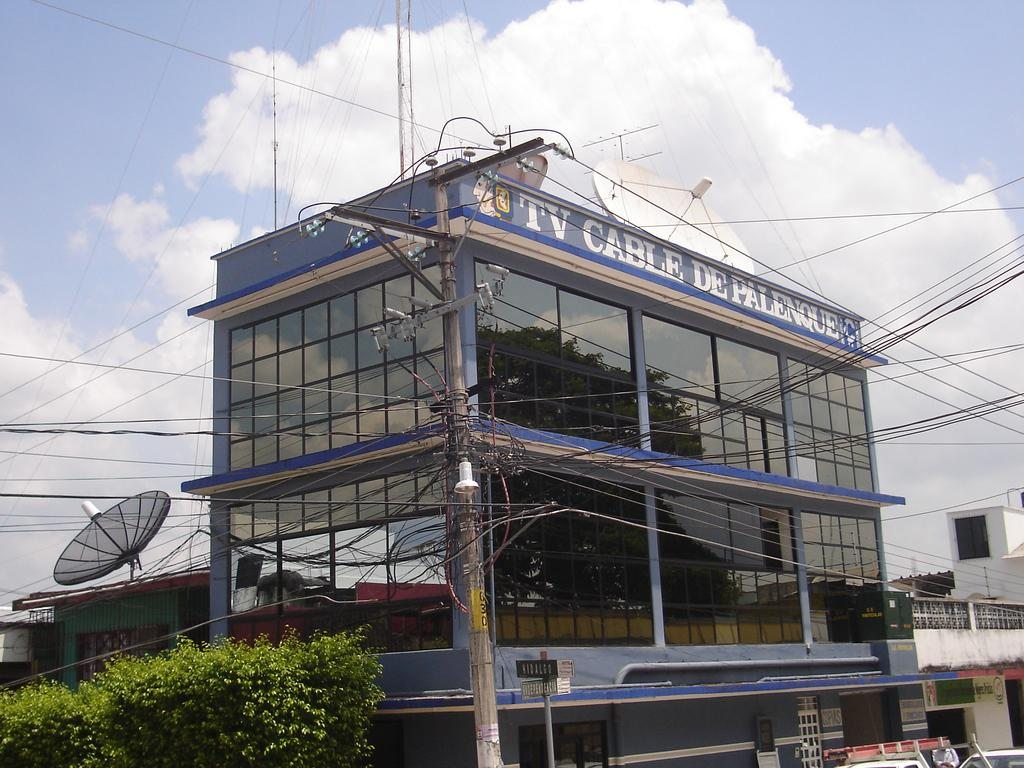What type of structure is present in the image? There is a building in the image. What type of vegetation is visible in the image? There are green trees in the image. What is visible at the top of the image? The sky is visible at the top of the image. What can be seen in the sky? There are clouds in the sky. How many patches are on the van in the image? There is no van present in the image, so there are no patches to count. What type of zephyr can be seen blowing through the trees in the image? There is no zephyr mentioned or visible in the image; it is a term for a gentle breeze, which cannot be seen. 